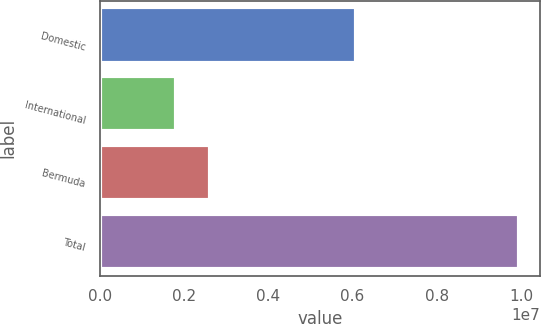Convert chart. <chart><loc_0><loc_0><loc_500><loc_500><bar_chart><fcel>Domestic<fcel>International<fcel>Bermuda<fcel>Total<nl><fcel>6.07873e+06<fcel>1.8022e+06<fcel>2.61716e+06<fcel>9.9518e+06<nl></chart> 